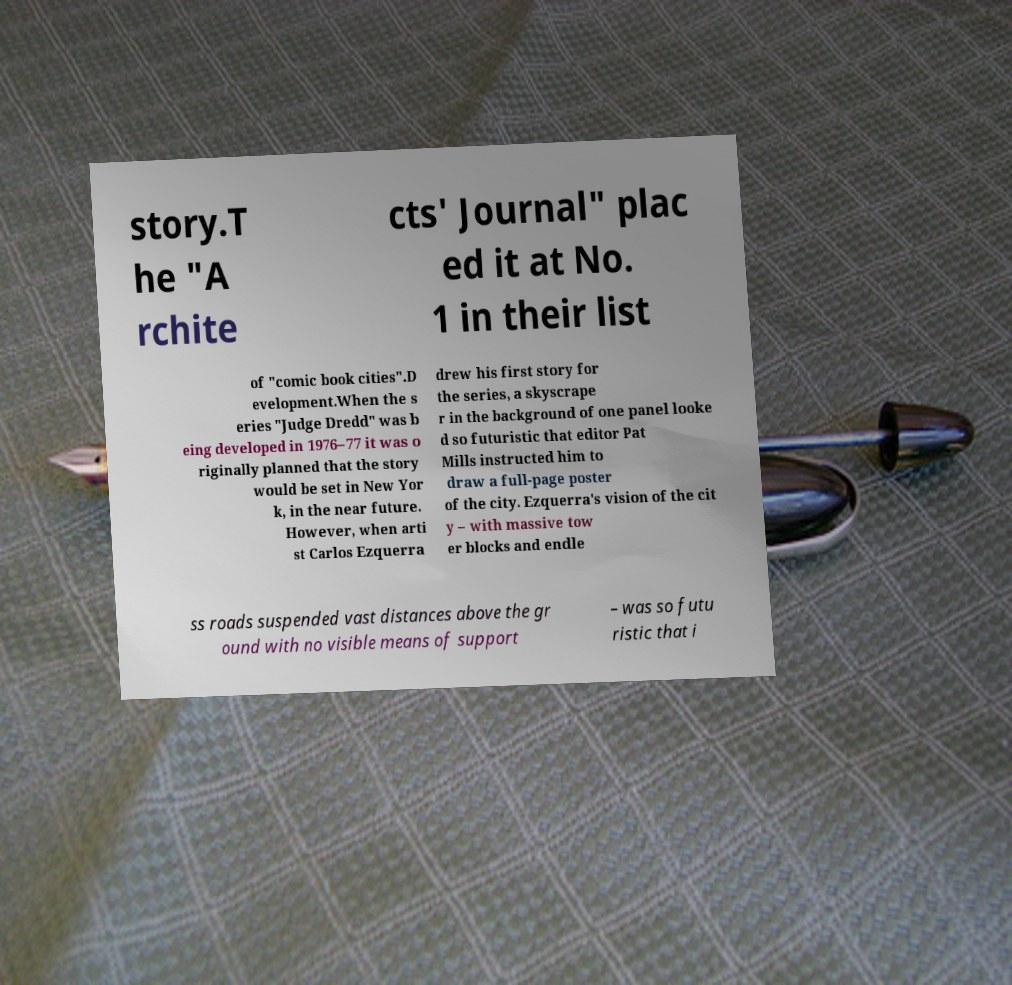Please read and relay the text visible in this image. What does it say? story.T he "A rchite cts' Journal" plac ed it at No. 1 in their list of "comic book cities".D evelopment.When the s eries "Judge Dredd" was b eing developed in 1976–77 it was o riginally planned that the story would be set in New Yor k, in the near future. However, when arti st Carlos Ezquerra drew his first story for the series, a skyscrape r in the background of one panel looke d so futuristic that editor Pat Mills instructed him to draw a full-page poster of the city. Ezquerra's vision of the cit y – with massive tow er blocks and endle ss roads suspended vast distances above the gr ound with no visible means of support – was so futu ristic that i 